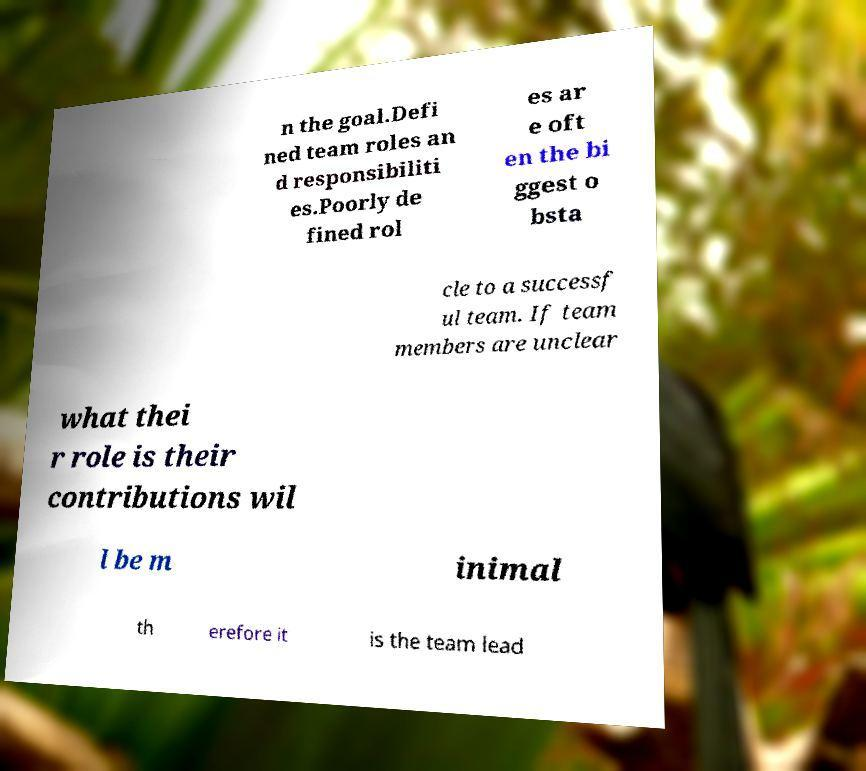Could you extract and type out the text from this image? n the goal.Defi ned team roles an d responsibiliti es.Poorly de fined rol es ar e oft en the bi ggest o bsta cle to a successf ul team. If team members are unclear what thei r role is their contributions wil l be m inimal th erefore it is the team lead 